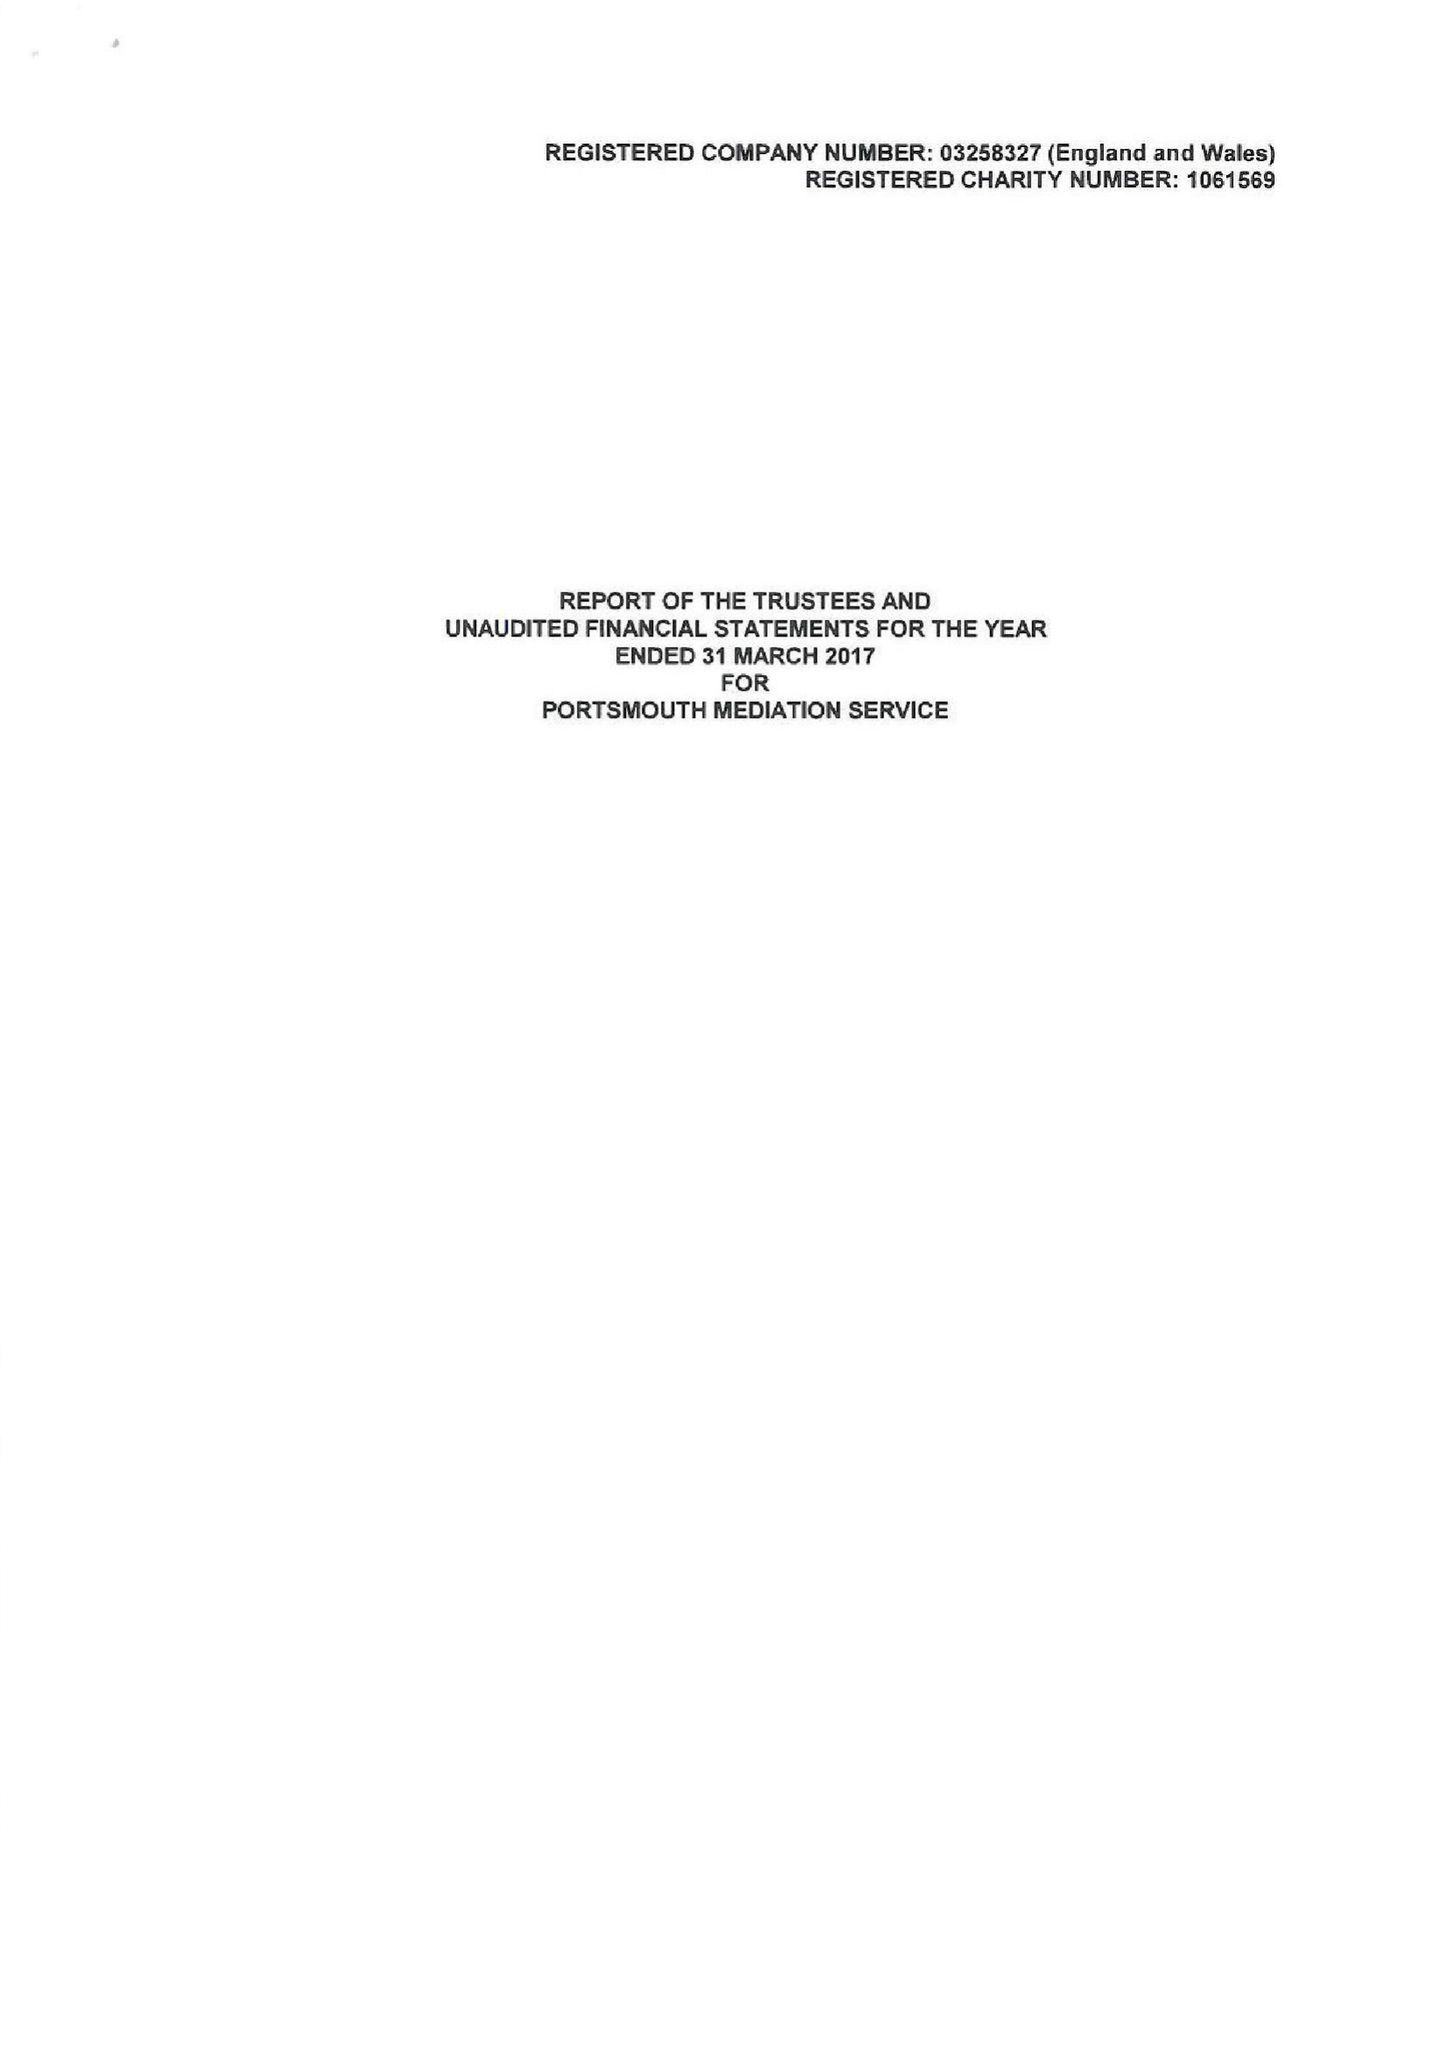What is the value for the charity_name?
Answer the question using a single word or phrase. Portsmouth Mediation Service 